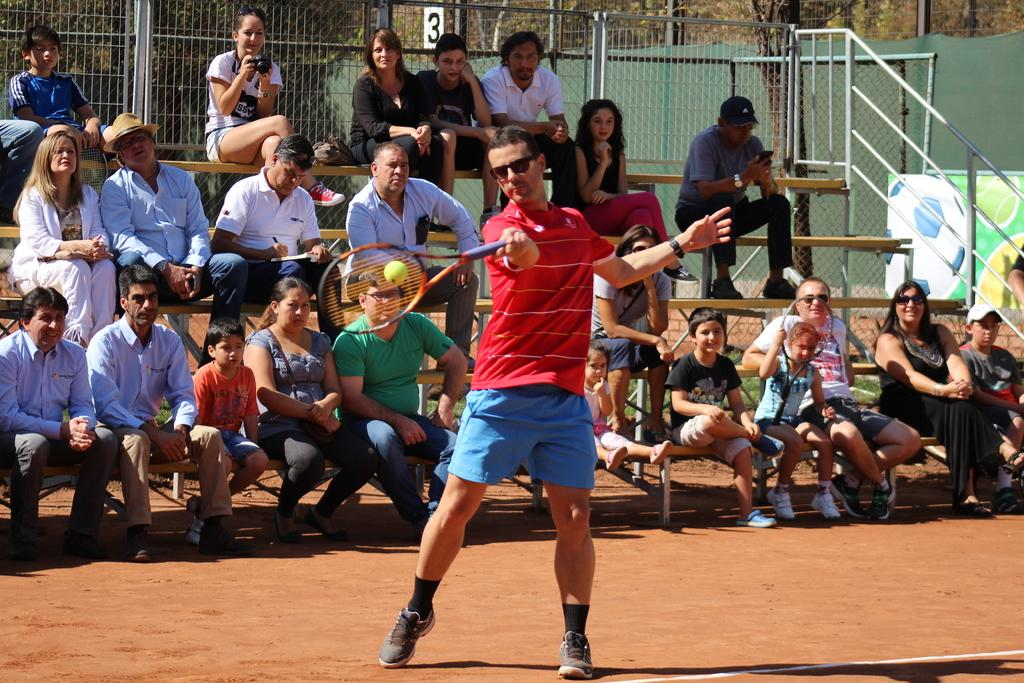<image>
Write a terse but informative summary of the picture. The number 3 is on a small white sign over the bleachers at this sporting venue. 